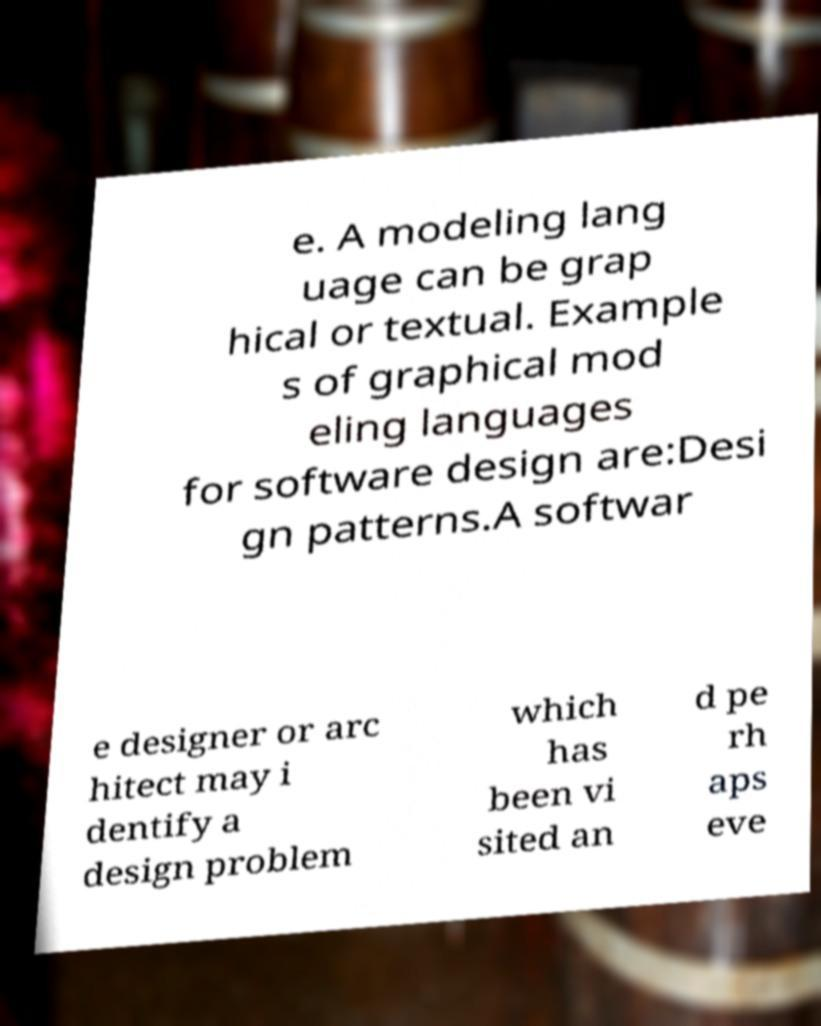Please identify and transcribe the text found in this image. e. A modeling lang uage can be grap hical or textual. Example s of graphical mod eling languages for software design are:Desi gn patterns.A softwar e designer or arc hitect may i dentify a design problem which has been vi sited an d pe rh aps eve 